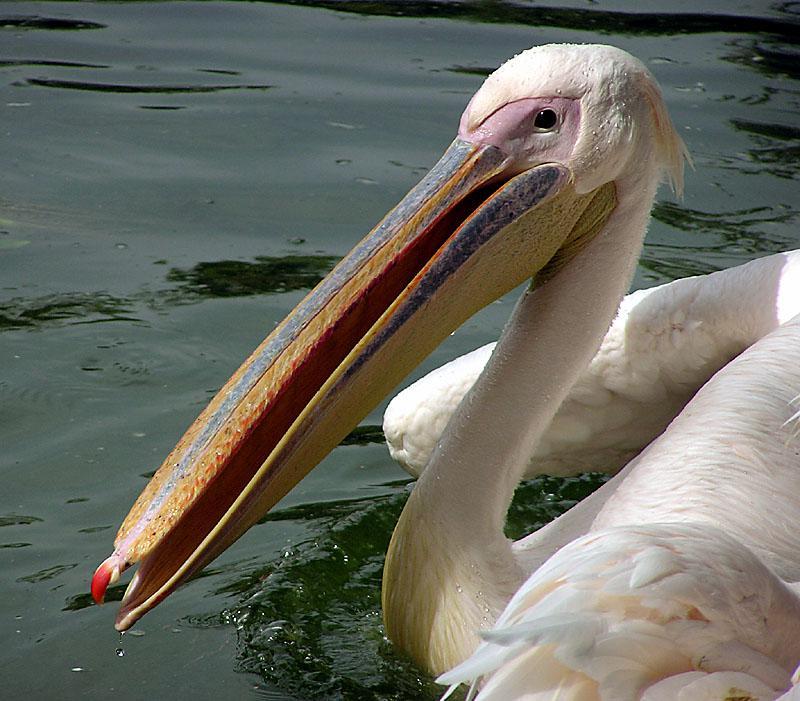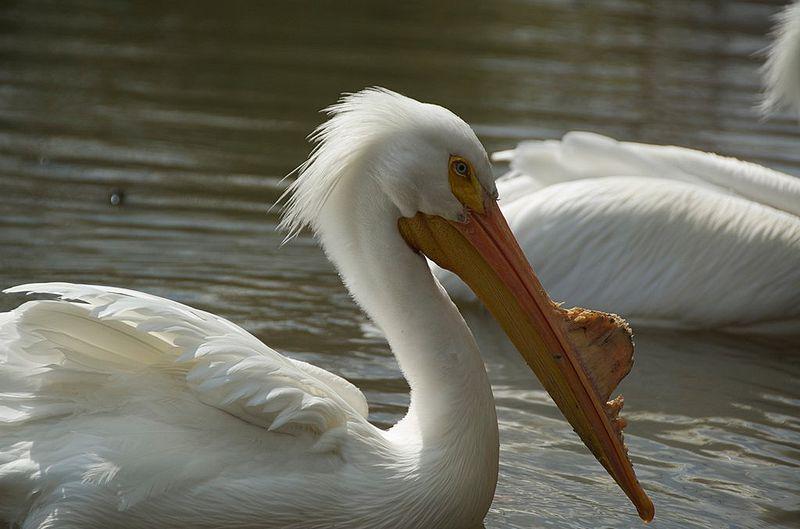The first image is the image on the left, the second image is the image on the right. Evaluate the accuracy of this statement regarding the images: "A fish is in a bird's mouth.". Is it true? Answer yes or no. No. 